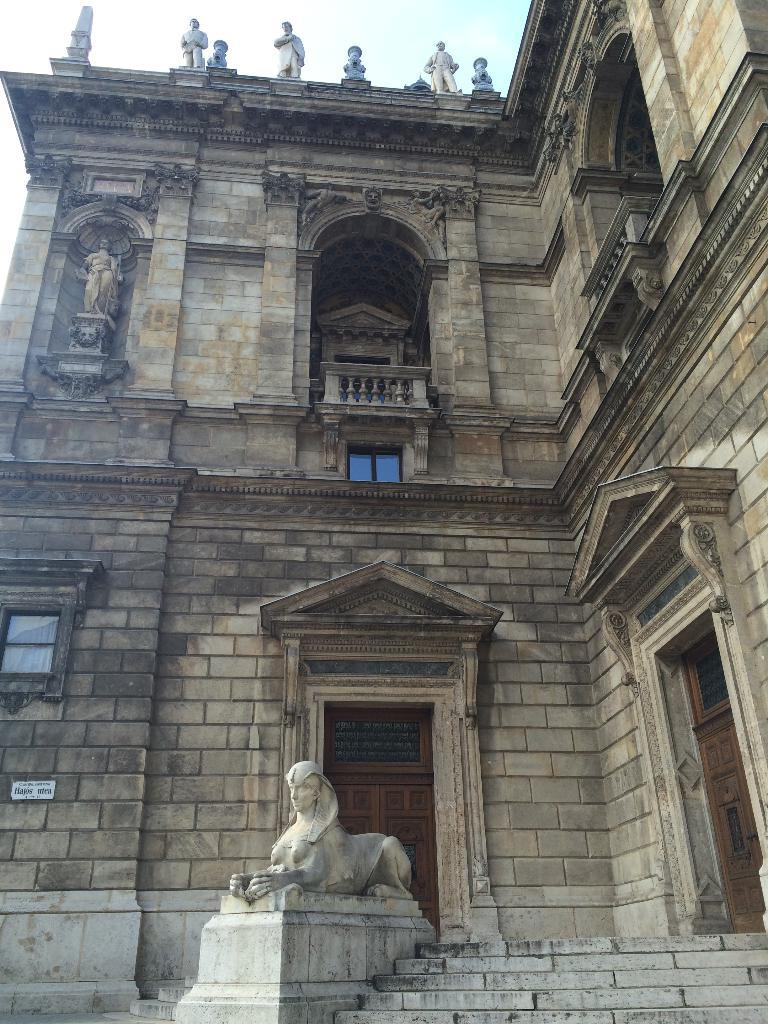What type of building is depicted in the image? There is a castle in the image. What material was used to construct the castle? The castle is constructed with stone bricks. Are there any other objects or structures near the castle? Yes, there are statues near the castle. What is the layout of the castle's entrance? There are stairs at the bottom of the castle, and a statue is located at the bottom of the stairs. Can you see a hand holding a twig in the image? No, there is no hand or twig present in the image. 